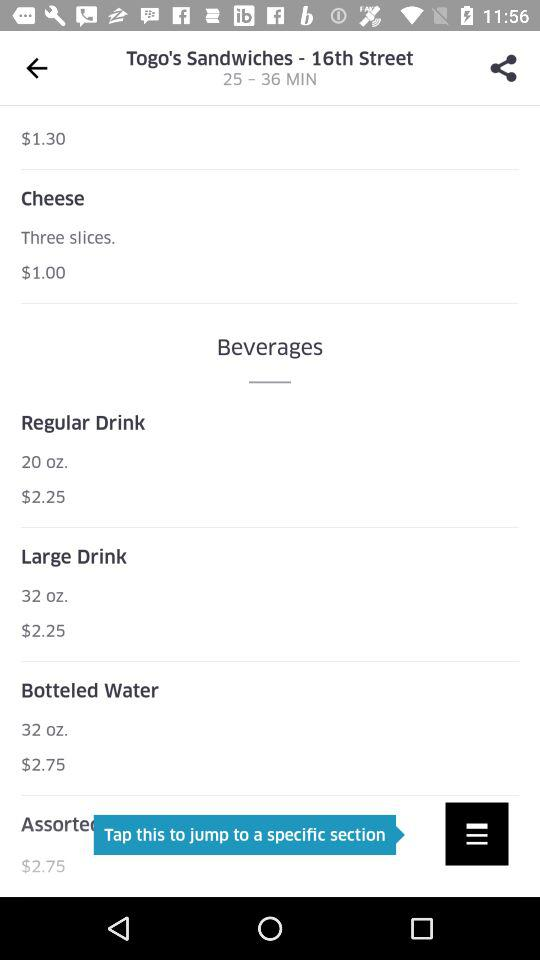What's the restaurant name? The restaurant name is "Tago's Sandwiches". 